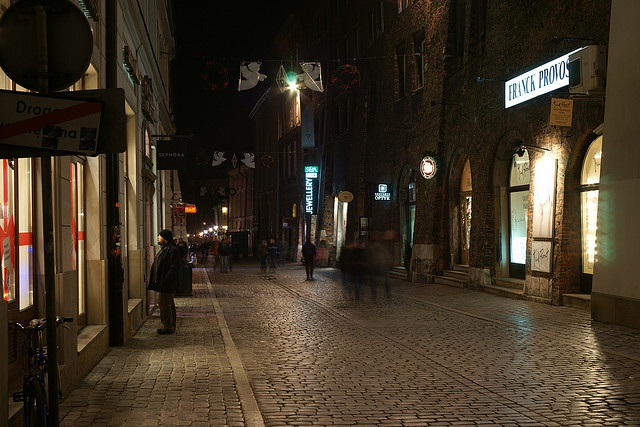Describe the objects in this image and their specific colors. I can see bicycle in maroon, black, and gray tones, people in maroon, black, and tan tones, people in black and maroon tones, people in maroon, black, gray, and brown tones, and people in black and maroon tones in this image. 